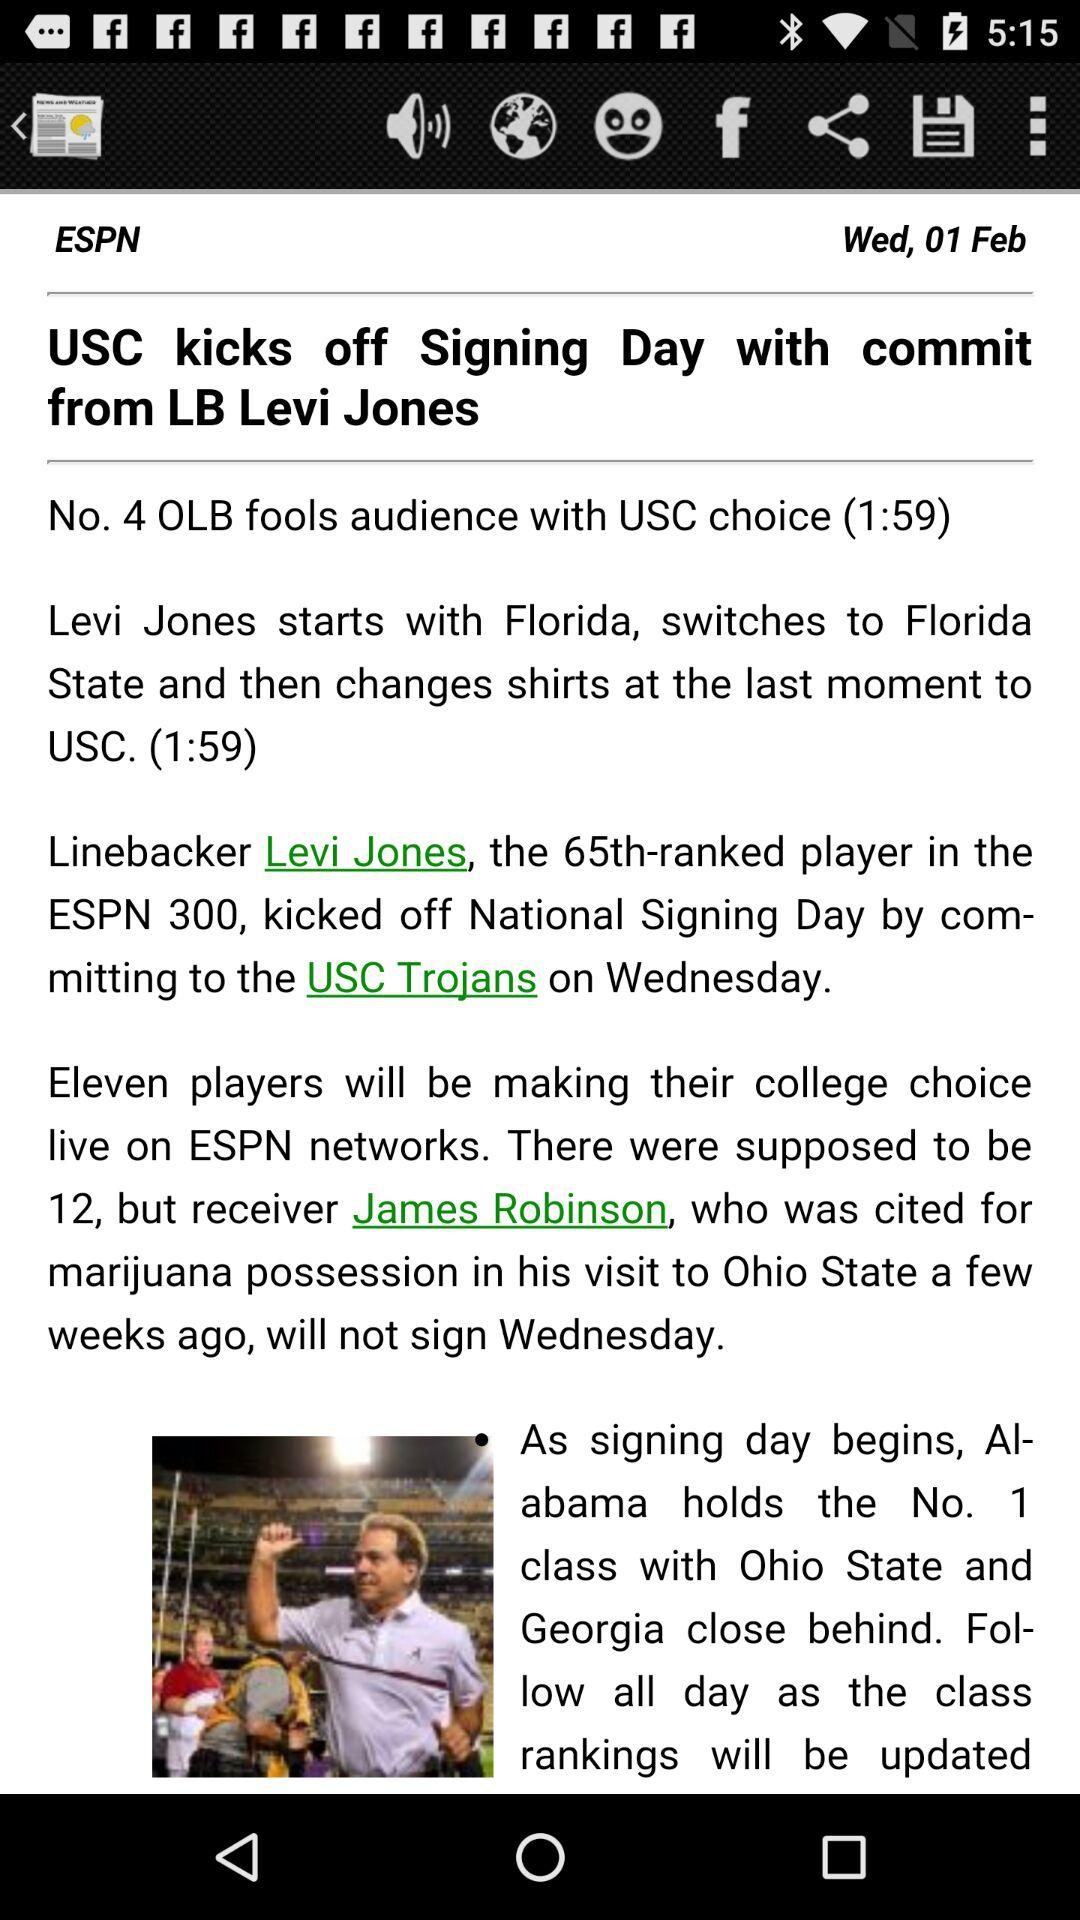What is the date? The date is Wednesday, February 1. 